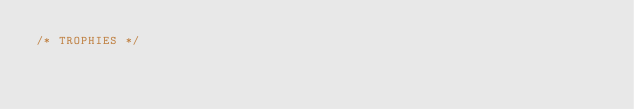Convert code to text. <code><loc_0><loc_0><loc_500><loc_500><_CSS_>/* TROPHIES */
</code> 